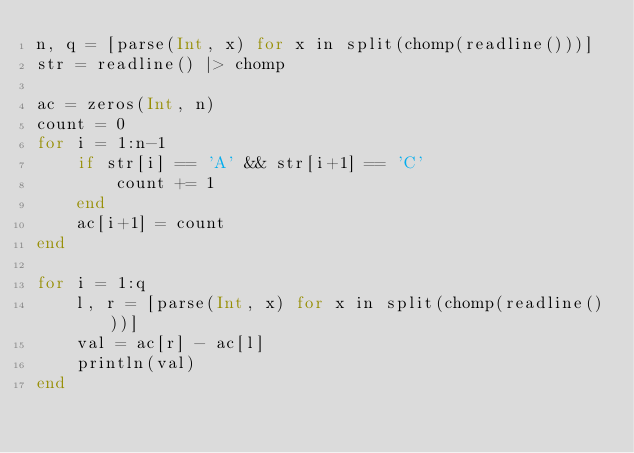Convert code to text. <code><loc_0><loc_0><loc_500><loc_500><_Julia_>n, q = [parse(Int, x) for x in split(chomp(readline()))]
str = readline() |> chomp

ac = zeros(Int, n)
count = 0
for i = 1:n-1
    if str[i] == 'A' && str[i+1] == 'C'
        count += 1
    end
    ac[i+1] = count
end

for i = 1:q
    l, r = [parse(Int, x) for x in split(chomp(readline()))]
    val = ac[r] - ac[l]
    println(val)
end</code> 